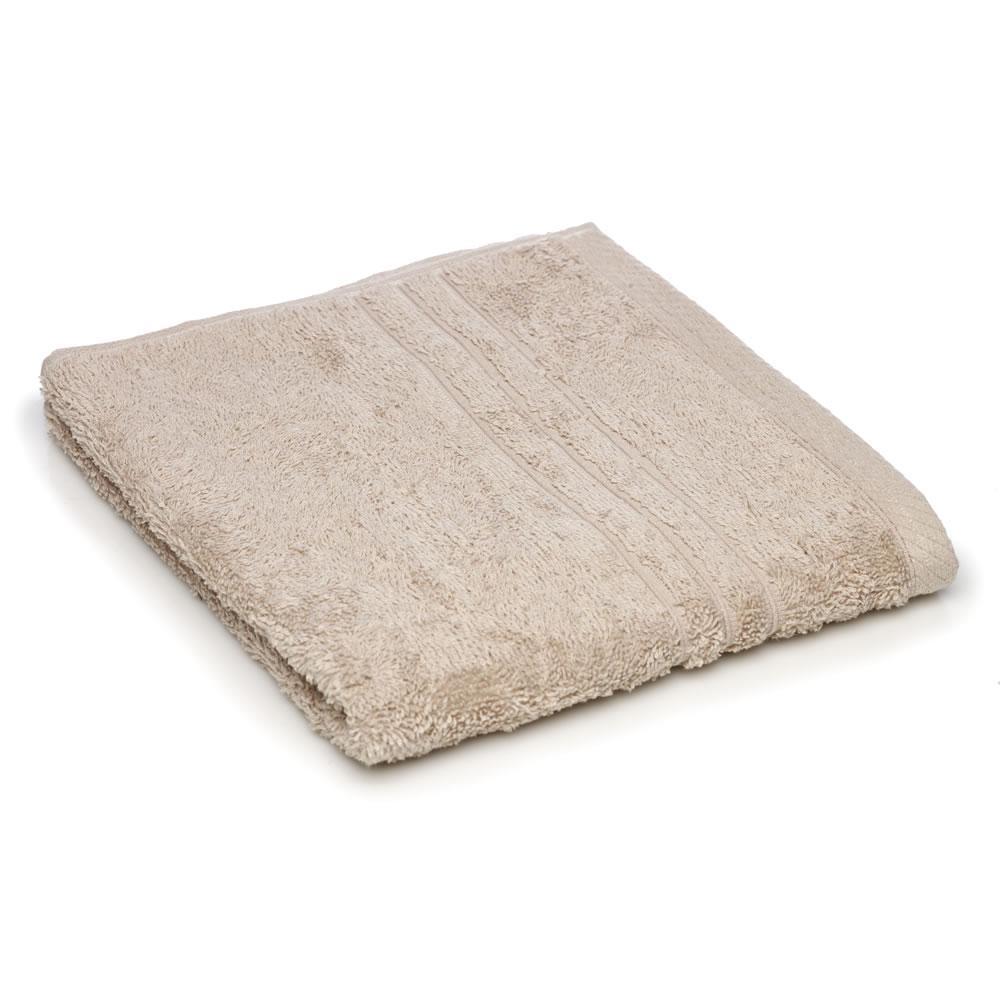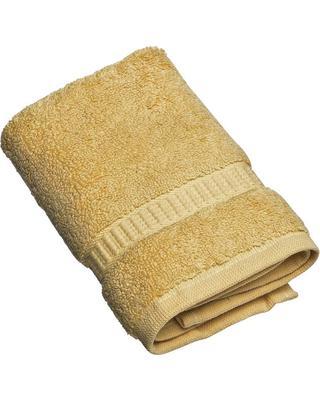The first image is the image on the left, the second image is the image on the right. For the images displayed, is the sentence "There are exactly two towels." factually correct? Answer yes or no. Yes. The first image is the image on the left, the second image is the image on the right. Analyze the images presented: Is the assertion "There is no less than six towels." valid? Answer yes or no. No. 